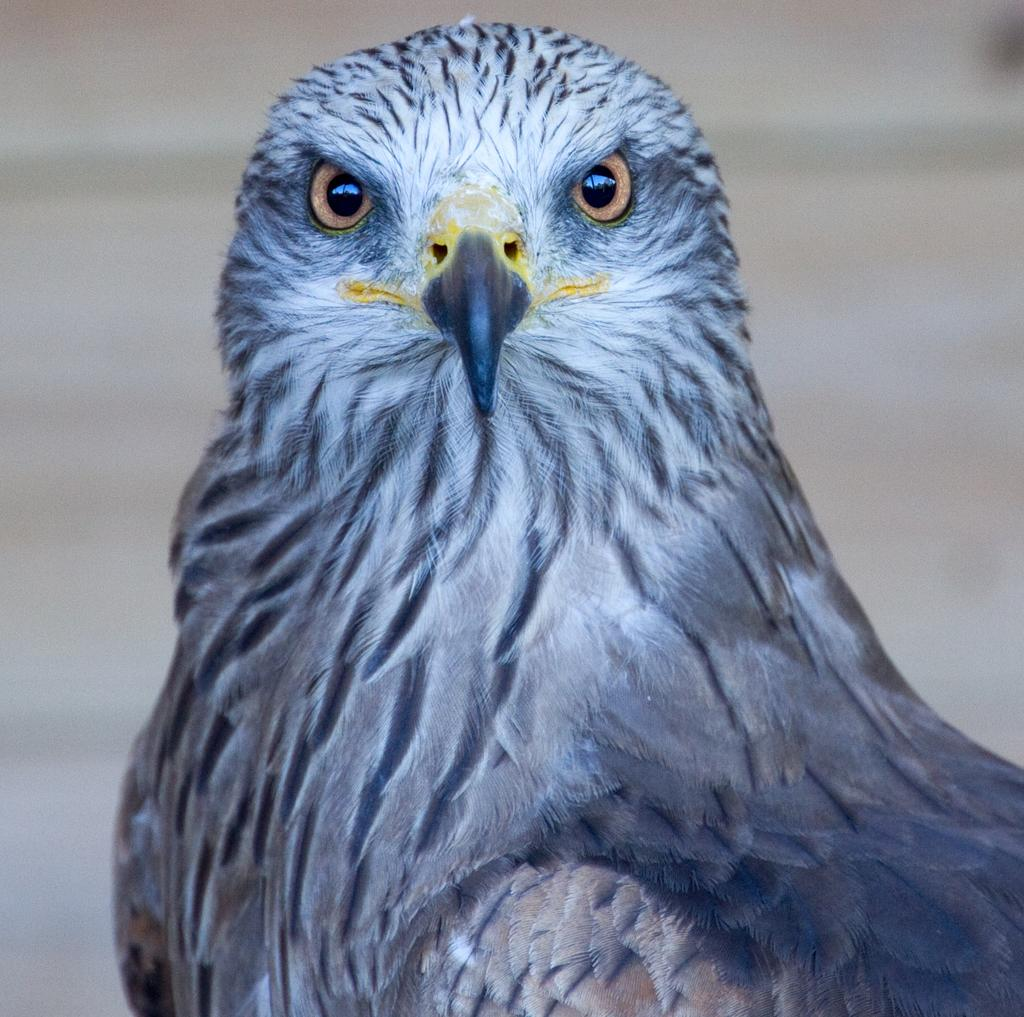What is the main subject in the foreground of the image? There is a bird in the foreground of the image. How would you describe the quality of the background in the image? The image is blurry in the background. What colors can be seen on the bird in the image? The bird has a blue and white coloration. Can you tell me how many friends the actor has in the image? There is no actor or friends present in the image; it features a bird in the foreground. What type of creature is shown interacting with the bird in the image? There is no creature shown interacting with the bird in the image; only the bird is present. 